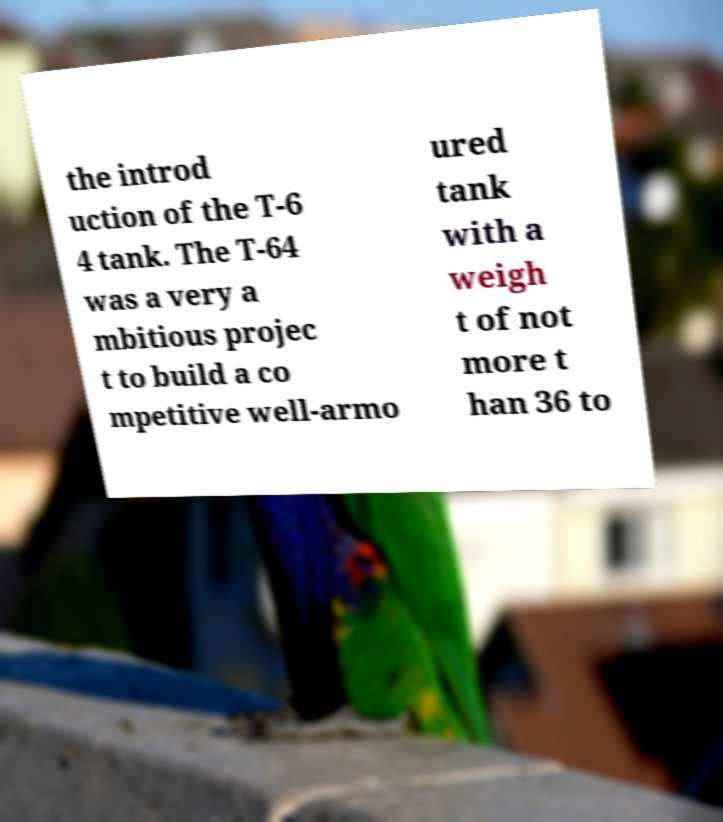Could you assist in decoding the text presented in this image and type it out clearly? the introd uction of the T-6 4 tank. The T-64 was a very a mbitious projec t to build a co mpetitive well-armo ured tank with a weigh t of not more t han 36 to 